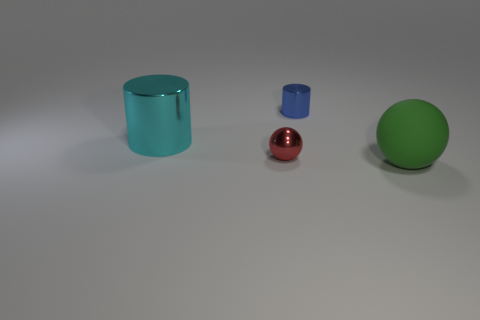There is a metallic cylinder to the right of the sphere left of the large ball; what number of shiny cylinders are in front of it?
Offer a terse response. 1. Are there more red metallic things than large red metal things?
Your answer should be very brief. Yes. What number of metal spheres are there?
Offer a terse response. 1. What shape is the tiny object that is in front of the cylinder that is behind the big thing left of the large green matte sphere?
Give a very brief answer. Sphere. Are there fewer cyan shiny cylinders that are right of the red object than cyan shiny cylinders that are behind the large cyan metallic cylinder?
Make the answer very short. No. There is a big thing that is behind the big green ball; is its shape the same as the metal thing on the right side of the red object?
Make the answer very short. Yes. There is a large thing that is to the right of the large object behind the big rubber thing; what is its shape?
Your answer should be compact. Sphere. Are there any other large spheres made of the same material as the large green sphere?
Offer a terse response. No. There is a large thing that is to the left of the green thing; what is it made of?
Give a very brief answer. Metal. What is the red sphere made of?
Provide a short and direct response. Metal. 